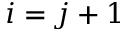<formula> <loc_0><loc_0><loc_500><loc_500>i = j + 1</formula> 